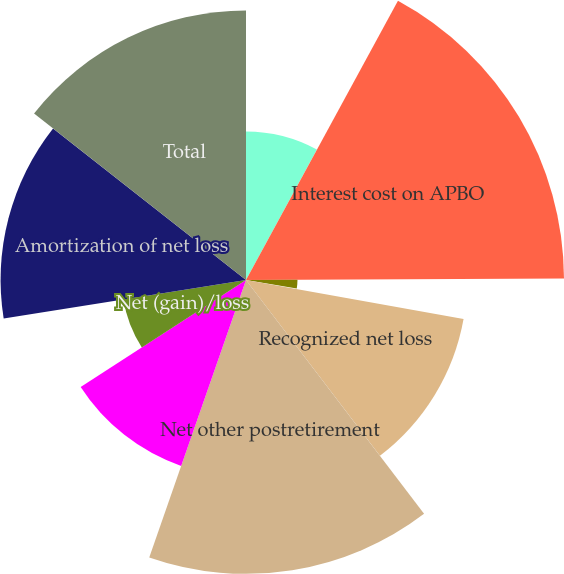<chart> <loc_0><loc_0><loc_500><loc_500><pie_chart><fcel>Service cost - benefits earned<fcel>Interest cost on APBO<fcel>Amortization of transition<fcel>Amortization of prior service<fcel>Recognized net loss<fcel>Net other postretirement<fcel>Prior service credit for<fcel>Net (gain)/loss<fcel>Amortization of net loss<fcel>Total<nl><fcel>7.93%<fcel>16.99%<fcel>2.75%<fcel>0.16%<fcel>11.81%<fcel>15.7%<fcel>10.52%<fcel>6.63%<fcel>13.11%<fcel>14.4%<nl></chart> 